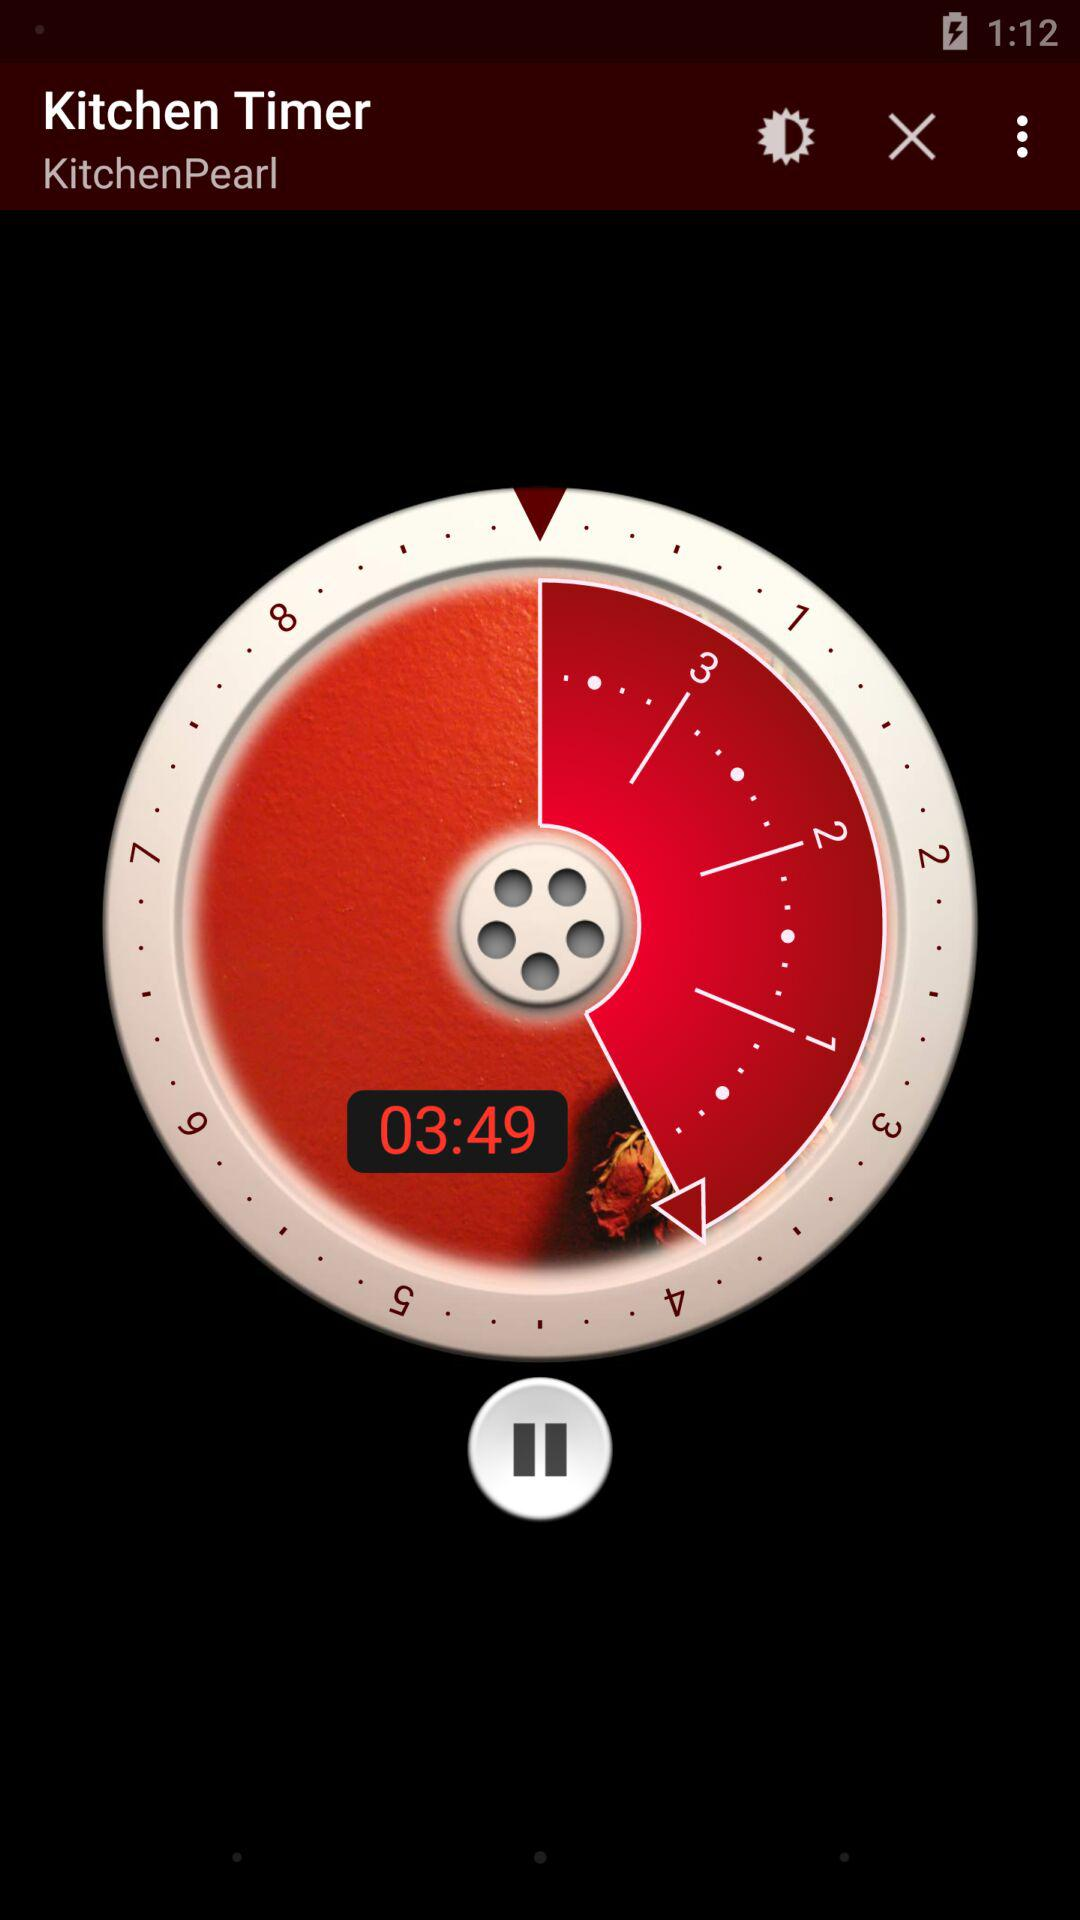What is the time given on the screen? The time given on the screen is 03:49. 